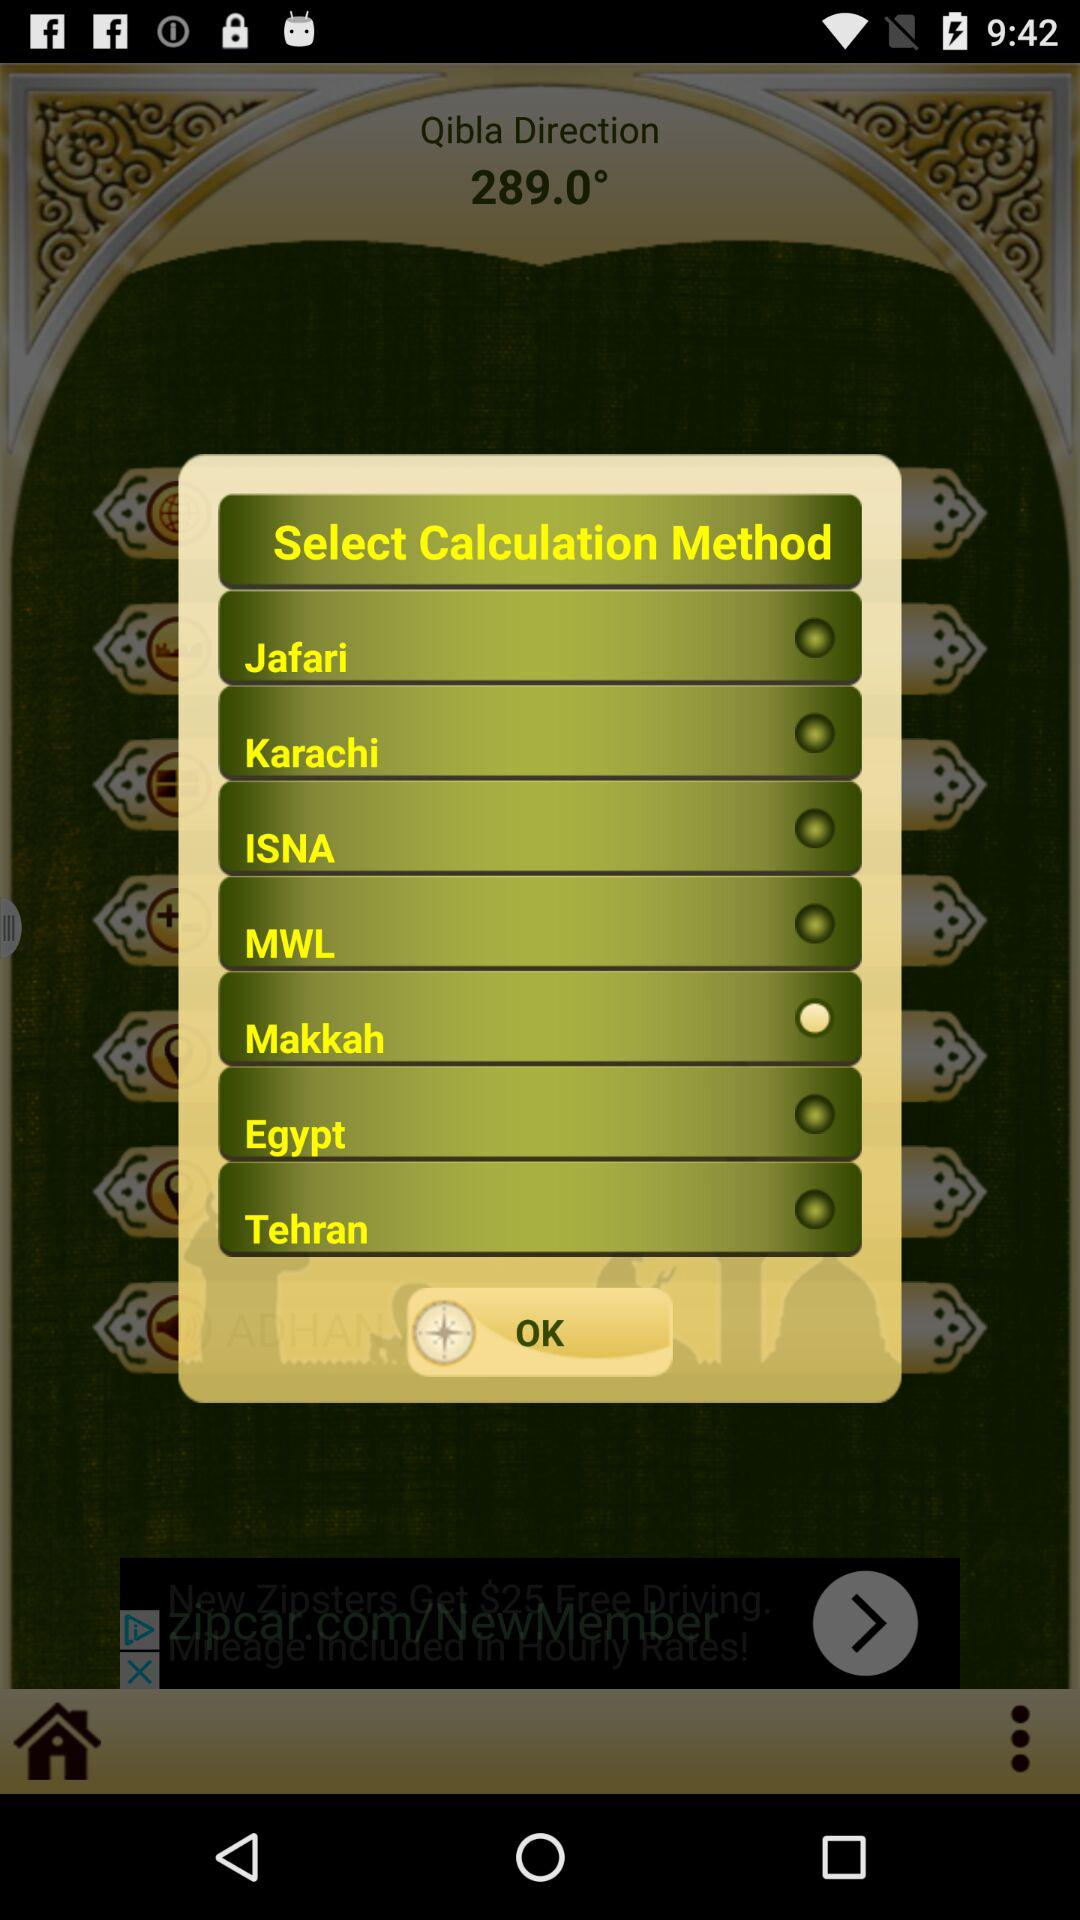Which calculation method is selected? The selected calculation method is "Makkah". 